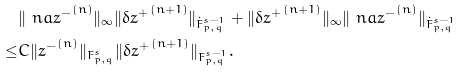Convert formula to latex. <formula><loc_0><loc_0><loc_500><loc_500>& \| \ n a { z ^ { - } } ^ { ( n ) } \| _ { \infty } \| \delta { z ^ { + } } ^ { ( n + 1 ) } \| _ { \dot { F } ^ { s - 1 } _ { p , q } } + \| \delta { z ^ { + } } ^ { ( n + 1 ) } \| _ { \infty } \| \ n a { z ^ { - } } ^ { ( n ) } \| _ { \dot { F } ^ { s - 1 } _ { p , q } } \\ \leq & C \| { z ^ { - } } ^ { ( n ) } \| _ { F ^ { s } _ { p , q } } \| \delta { z ^ { + } } ^ { ( n + 1 ) } \| _ { F ^ { s - 1 } _ { p , q } } .</formula> 